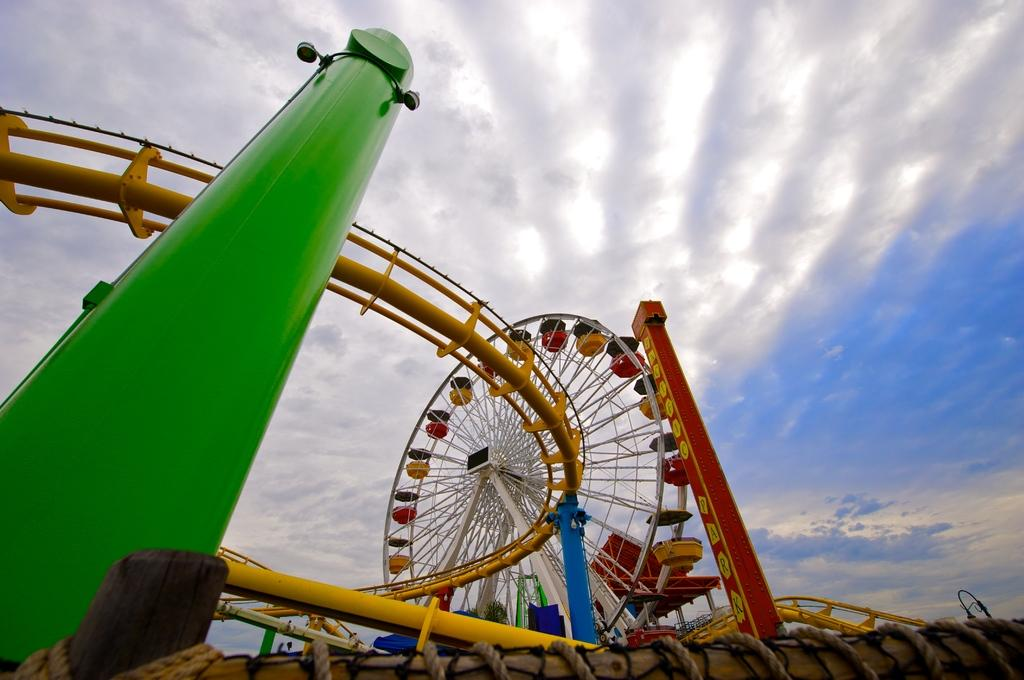What structures are present in the image? There are poles, lights, ropes, and rods in the image. What is the main feature in the image? There is a giant wheel in the image. What can be seen in the background of the image? The sky is visible in the background of the image, and clouds are present in the sky. What type of thunder can be heard in the image? There is no thunder present in the image, as it is a visual representation and does not include sound. On which side of the image are the ropes located? The image is a two-dimensional representation, so it does not have sides. The ropes are present within the image, but their position relative to the edges cannot be determined. 